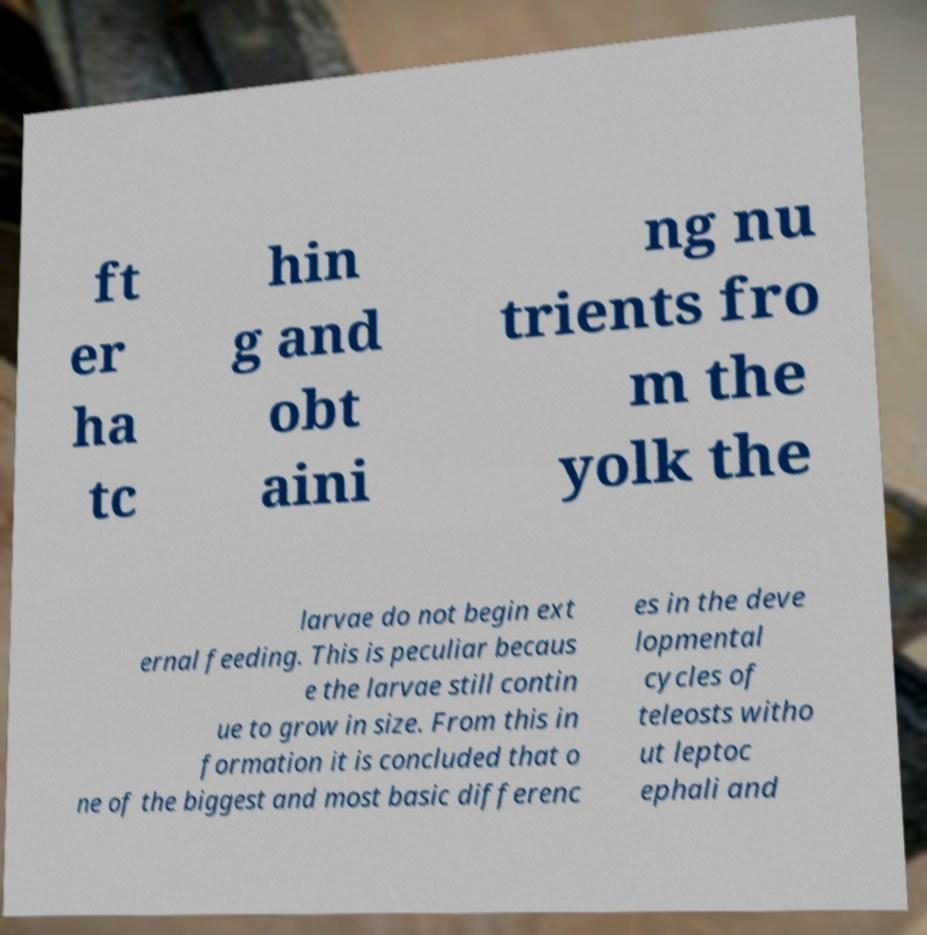I need the written content from this picture converted into text. Can you do that? ft er ha tc hin g and obt aini ng nu trients fro m the yolk the larvae do not begin ext ernal feeding. This is peculiar becaus e the larvae still contin ue to grow in size. From this in formation it is concluded that o ne of the biggest and most basic differenc es in the deve lopmental cycles of teleosts witho ut leptoc ephali and 